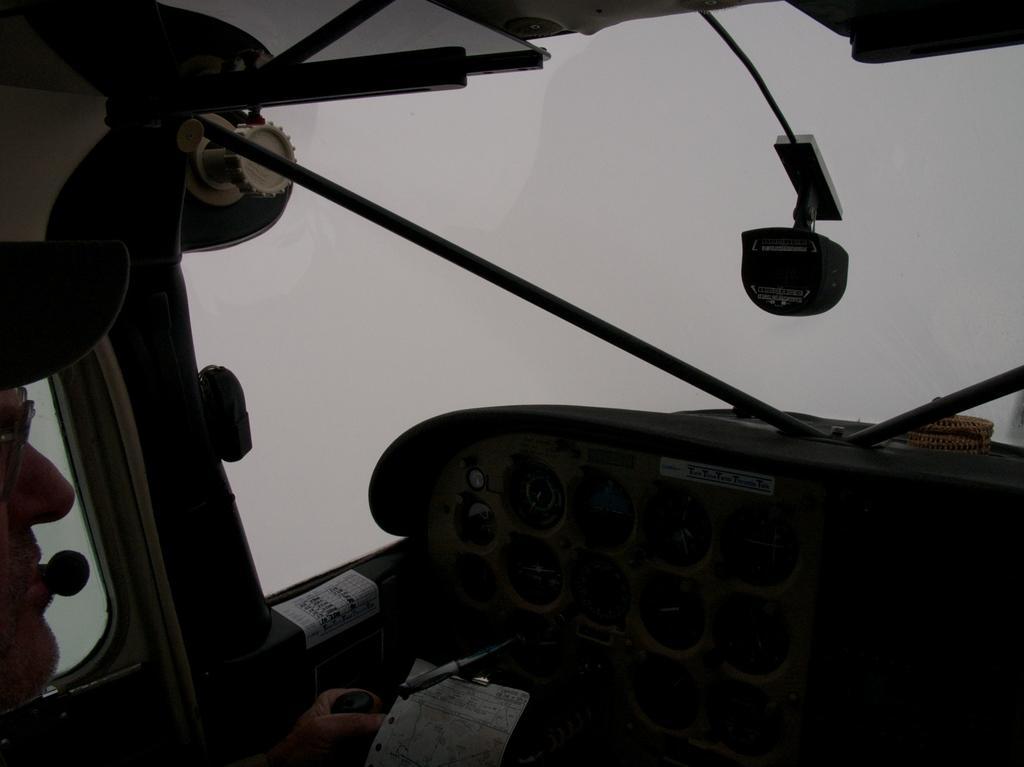Can you describe this image briefly? In this picture we can see the inside views of the helicopter. In the front there is a cluster unit and windshield glass. 